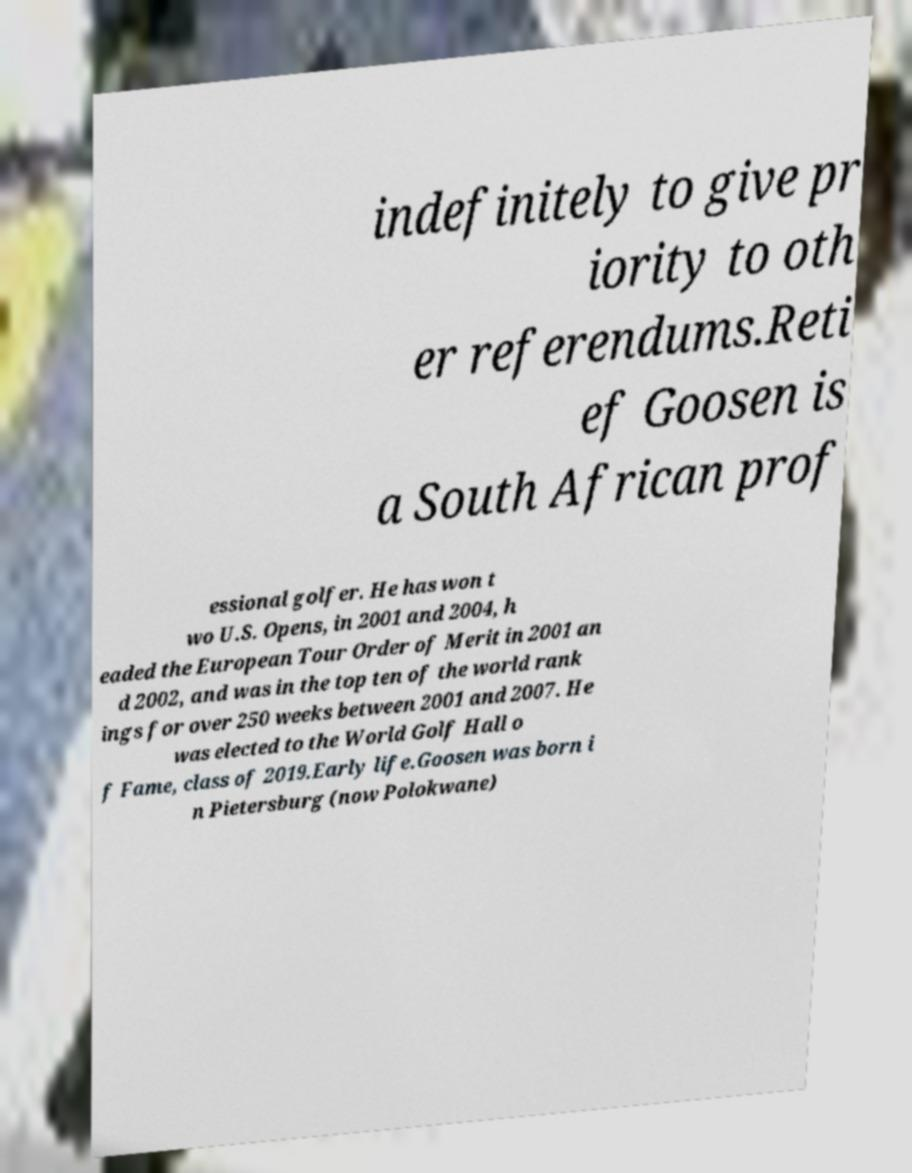Could you extract and type out the text from this image? indefinitely to give pr iority to oth er referendums.Reti ef Goosen is a South African prof essional golfer. He has won t wo U.S. Opens, in 2001 and 2004, h eaded the European Tour Order of Merit in 2001 an d 2002, and was in the top ten of the world rank ings for over 250 weeks between 2001 and 2007. He was elected to the World Golf Hall o f Fame, class of 2019.Early life.Goosen was born i n Pietersburg (now Polokwane) 